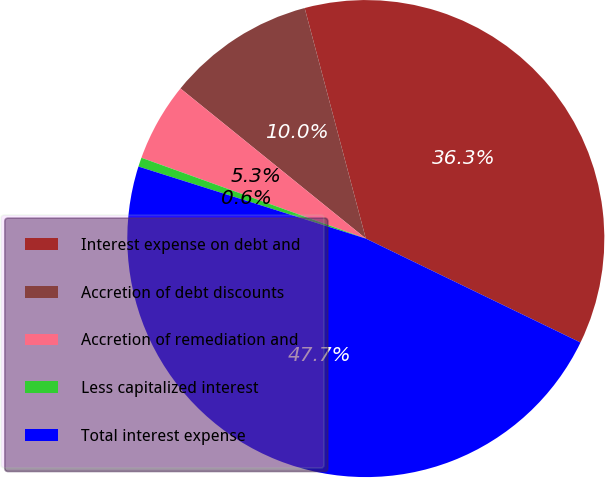Convert chart. <chart><loc_0><loc_0><loc_500><loc_500><pie_chart><fcel>Interest expense on debt and<fcel>Accretion of debt discounts<fcel>Accretion of remediation and<fcel>Less capitalized interest<fcel>Total interest expense<nl><fcel>36.3%<fcel>10.04%<fcel>5.33%<fcel>0.62%<fcel>47.7%<nl></chart> 